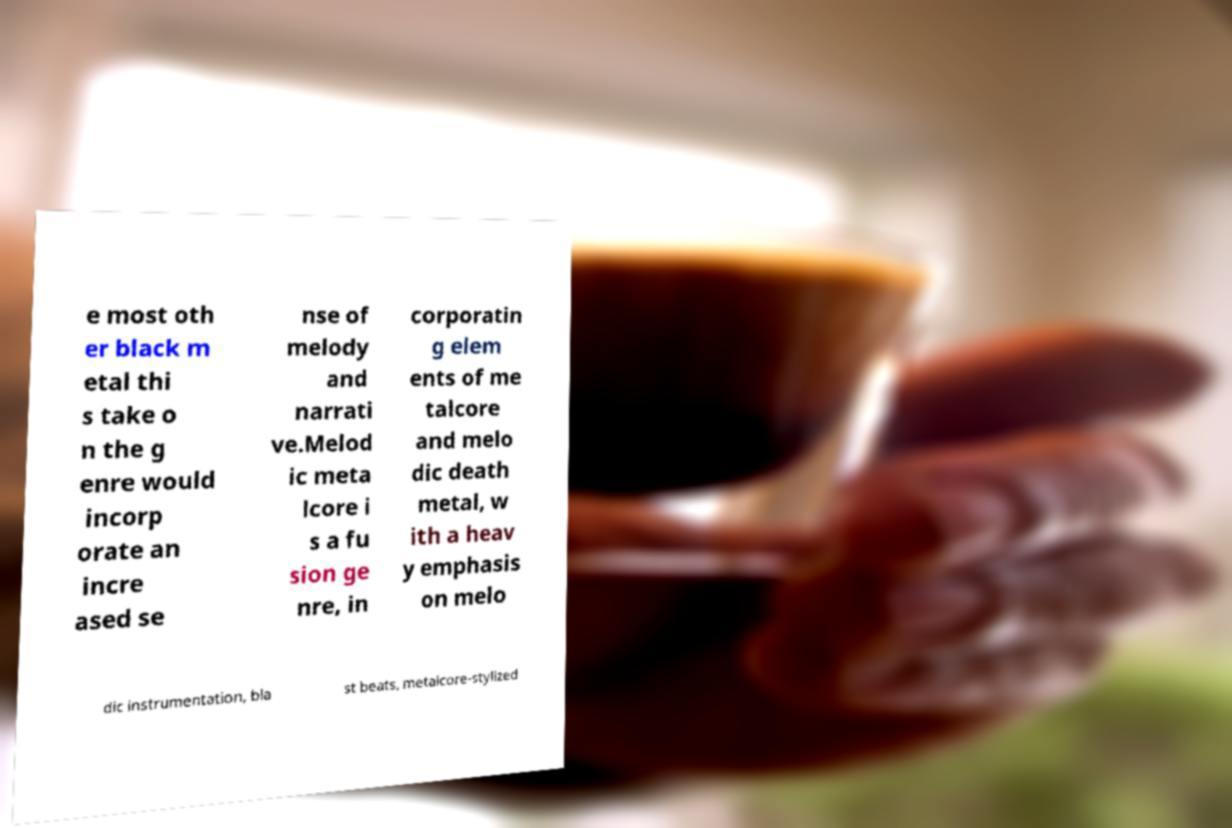I need the written content from this picture converted into text. Can you do that? e most oth er black m etal thi s take o n the g enre would incorp orate an incre ased se nse of melody and narrati ve.Melod ic meta lcore i s a fu sion ge nre, in corporatin g elem ents of me talcore and melo dic death metal, w ith a heav y emphasis on melo dic instrumentation, bla st beats, metalcore-stylized 